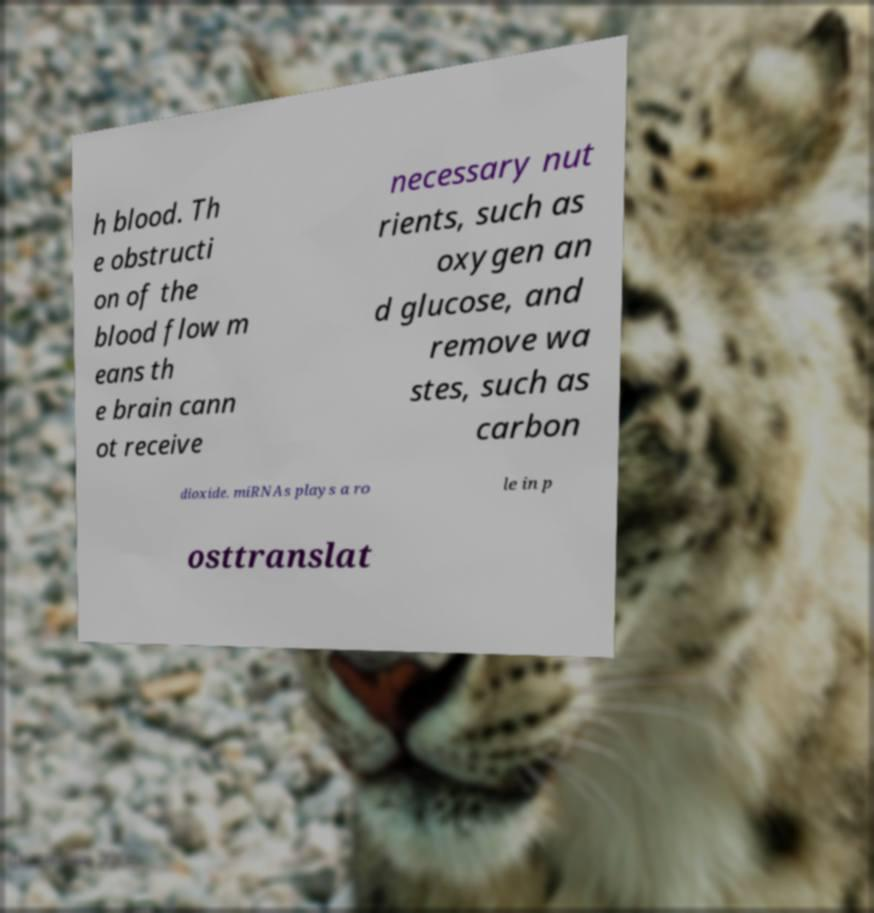What messages or text are displayed in this image? I need them in a readable, typed format. h blood. Th e obstructi on of the blood flow m eans th e brain cann ot receive necessary nut rients, such as oxygen an d glucose, and remove wa stes, such as carbon dioxide. miRNAs plays a ro le in p osttranslat 